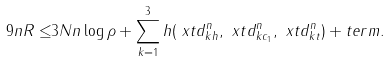Convert formula to latex. <formula><loc_0><loc_0><loc_500><loc_500>9 n R \leq & 3 N n \log \rho + \sum _ { k = 1 } ^ { 3 } h ( \ x t d _ { k h } ^ { n } , \ x t d _ { k c _ { 1 } } ^ { n } , \ x t d _ { k t } ^ { n } ) + t e r m .</formula> 